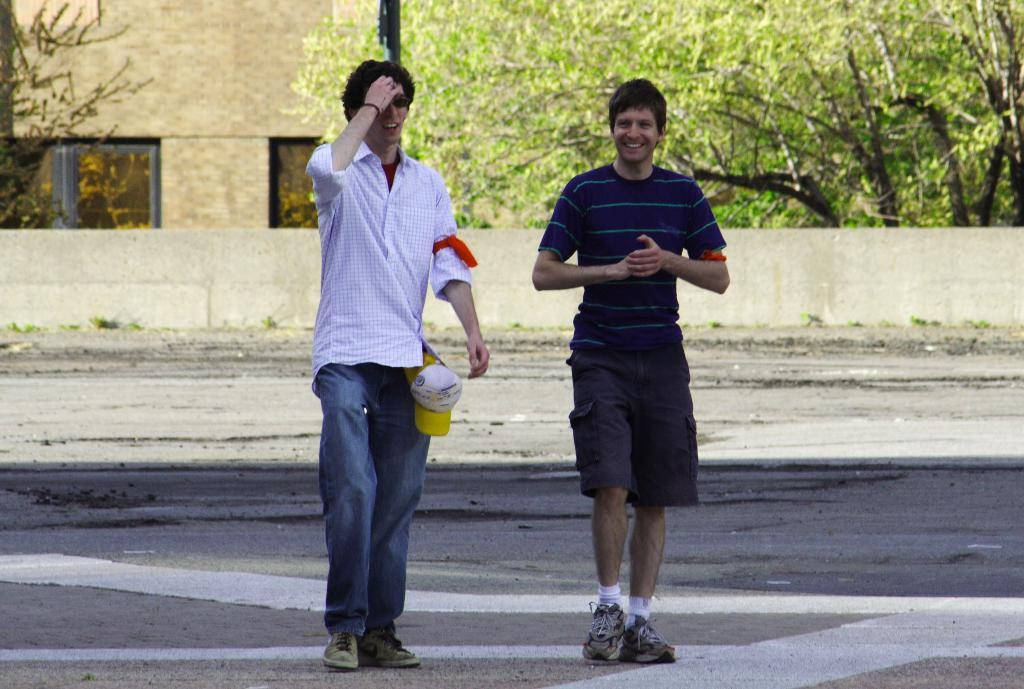How many people are in the image? There are two persons in the image. What are the persons doing in the image? The persons are walking on a road. What can be seen in the background of the image? There is a wall, trees, and a building in the background of the image. What type of advertisement can be seen on the wall in the image? There is no advertisement visible on the wall in the image. Is the queen present in the image? There is no queen present in the image; it features two persons walking on a road. 